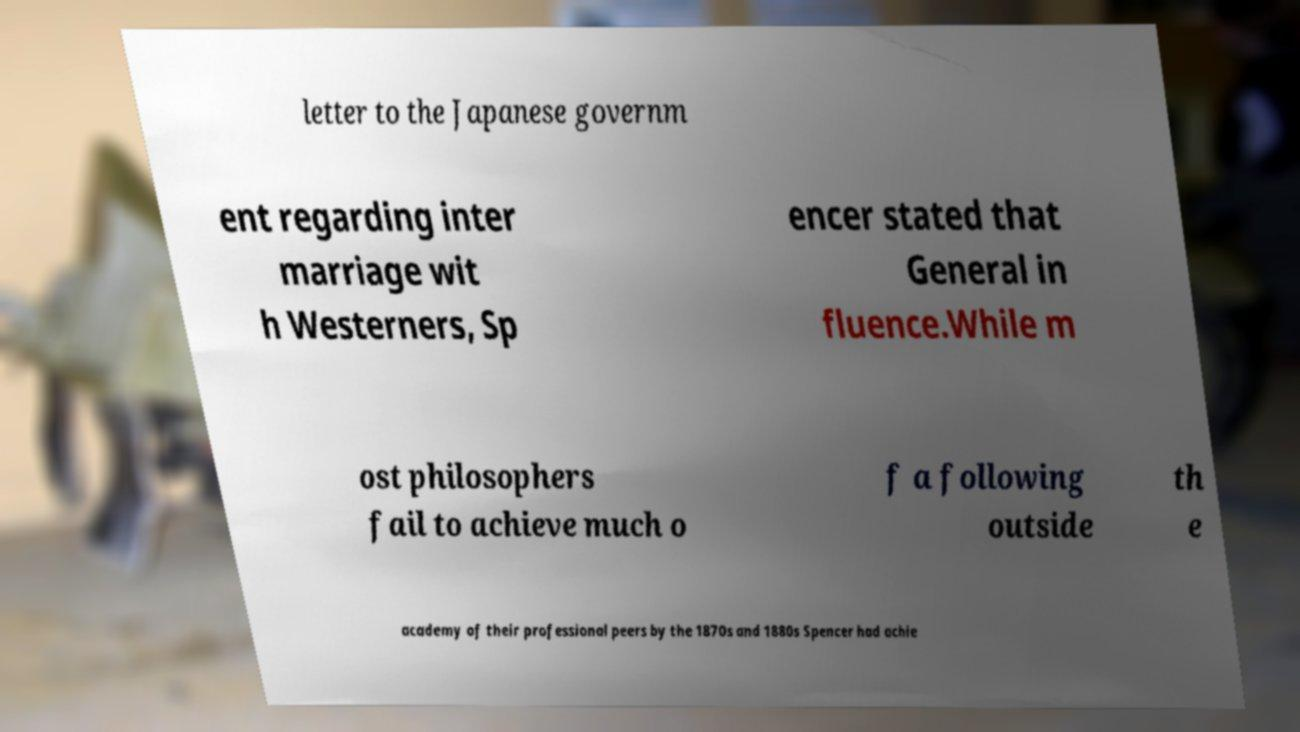Could you assist in decoding the text presented in this image and type it out clearly? letter to the Japanese governm ent regarding inter marriage wit h Westerners, Sp encer stated that General in fluence.While m ost philosophers fail to achieve much o f a following outside th e academy of their professional peers by the 1870s and 1880s Spencer had achie 